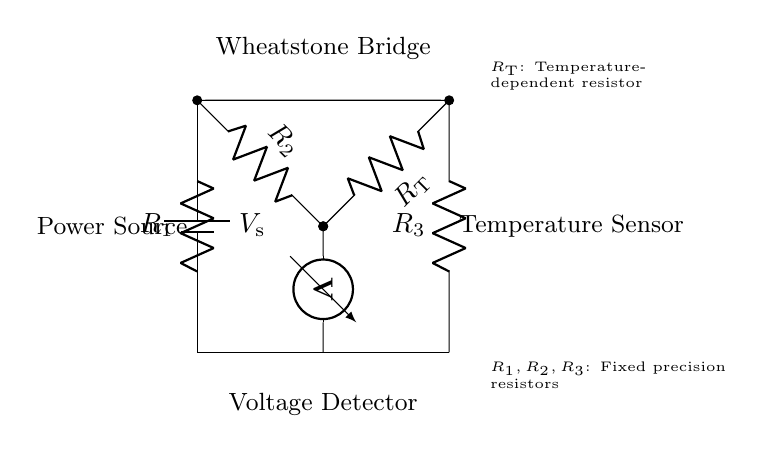What is the main purpose of the Wheatstone bridge in this circuit? The Wheatstone bridge is used for precise measurement of resistance, which in this case correlates to temperature.
Answer: Precise temperature measurement What type of components are R1, R2, and R3? R1, R2, and R3 are fixed precision resistors used to balance the bridge for accurate measurements.
Answer: Fixed precision resistors What does R_T represent in the circuit? R_T represents a temperature-dependent resistor, which changes resistance based on temperature fluctuations.
Answer: Temperature-dependent resistor How many resistors are there in the Wheatstone bridge? There are four resistors in the Wheatstone bridge arrangement: R1, R2, R3, and R_T.
Answer: Four resistors What is the role of the voltmeter in the circuit? The voltmeter measures the voltage difference across the center of the bridge, indicating balance or imbalance, related to resistance changes.
Answer: Measure voltage difference If R_T increases, what happens to the measured voltage? If R_T increases, the voltage measured by the voltmeter will change, indicating a change in resistance that corresponds to a temperature increase.
Answer: Voltage changes 